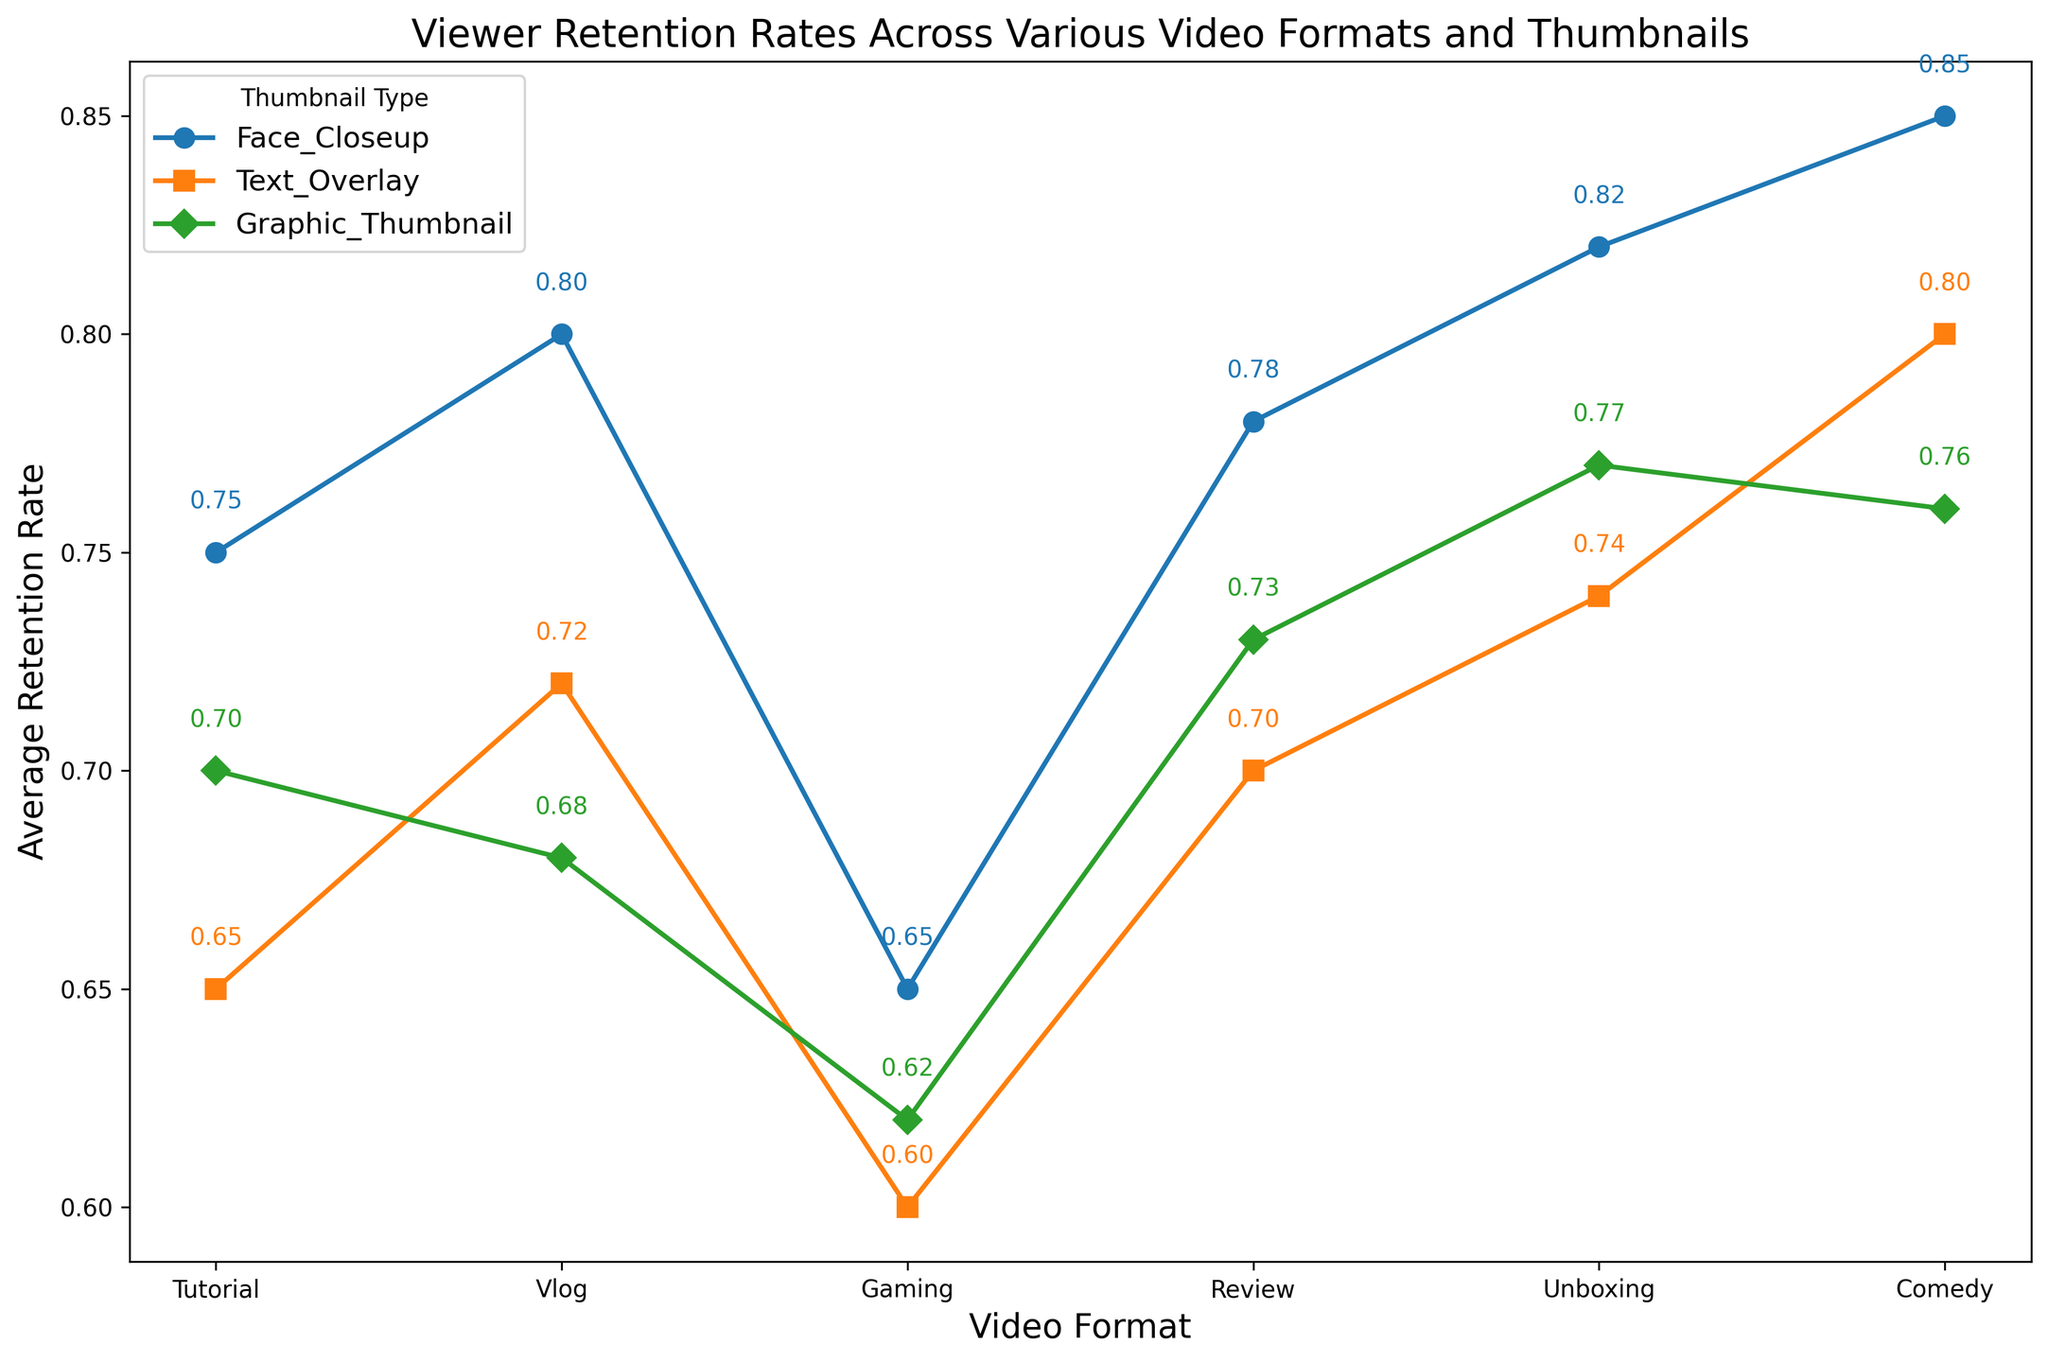What is the viewer retention rate for Tutorial videos with Face Closeup thumbnails? To determine the viewer retention rate for Tutorial videos with Face Closeup thumbnails, locate the point where the 'Face Closeup' marker intersects with the 'Tutorial' category on the x-axis. The text annotation next to this marker shows the rate.
Answer: 0.75 Which video format has the highest average retention rate with Graphic Thumbnail type? To find the highest average retention rate for videos within the Graphic Thumbnail type, compare the height of the markers (or check the text annotations) for each video format within this thumbnail type group.
Answer: Unboxing How much higher is the retention rate for Vlog videos with Face Closeup thumbnails compared to Gaming videos with the same thumbnail type? First, identify the retention rates for Vlog and Gaming videos with Face Closeup thumbnails (0.80 and 0.65, respectively). Then subtract the Gaming rate from the Vlog rate: 0.80 - 0.65 = 0.15
Answer: 0.15 Which thumbnail type generally shows the best retention rates across most video formats? Observe the series of lines and markers for each thumbnail type across various video formats. The one appearing highest across most categories will indicate the best retention rates.
Answer: Face Closeup What is the difference in retention rate between Comedy videos with Face Closeup thumbnails and Text Overlay thumbnails? Determine the retention rates for Comedy videos with Face Closeup (0.85) and Text Overlay (0.80) thumbnails. Subtract the Text Overlay rate from the Face Closeup rate: 0.85 - 0.80 = 0.05
Answer: 0.05 What is the average retention rate for Review videos using all three thumbnail types? Identify the retention rates for Review videos across Face Closeup (0.78), Text Overlay (0.70), and Graphic Thumbnail (0.73) types. Calculate the average: (0.78 + 0.70 + 0.73) / 3 = 0.73
Answer: 0.73 How does the retention rate for Unboxing videos with Text Overlay thumbnails compare to Review videos with the same thumbnail type? Identify the retention rates for Unboxing (0.74) and Review (0.70) videos with Text Overlay thumbnails. Then compare the values: 0.74 > 0.70. Unboxing has a higher retention rate.
Answer: Unboxing has a higher retention rate Which video format has the lowest retention rate with Text Overlay thumbnails? Among the video formats using Text Overlay thumbnails, compare the text annotations to find the lowest retention rate.
Answer: Gaming Which thumbnail type has the lowest retention rate for Vlogs? Observe the markers for Vlogs and identify the lowest retention rate from the text annotations for the three thumbnail types: Face Closeup, Text Overlay, and Graphic Thumbnail.
Answer: Graphic Thumbnail For Unboxing videos, how much higher is the retention rate with Graphic Thumbnail compared to Gaming videos with Graphic Thumbnail? First, note the retention rates for Unboxing (0.77) and Gaming (0.62) with Graphic Thumbnails. The difference is calculated as 0.77 - 0.62 = 0.15
Answer: 0.15 